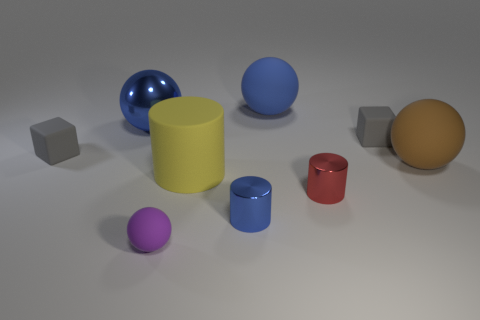Add 1 big yellow cylinders. How many objects exist? 10 Subtract all spheres. How many objects are left? 5 Subtract all large matte cylinders. Subtract all big shiny objects. How many objects are left? 7 Add 6 small gray things. How many small gray things are left? 8 Add 4 purple rubber things. How many purple rubber things exist? 5 Subtract 0 gray cylinders. How many objects are left? 9 